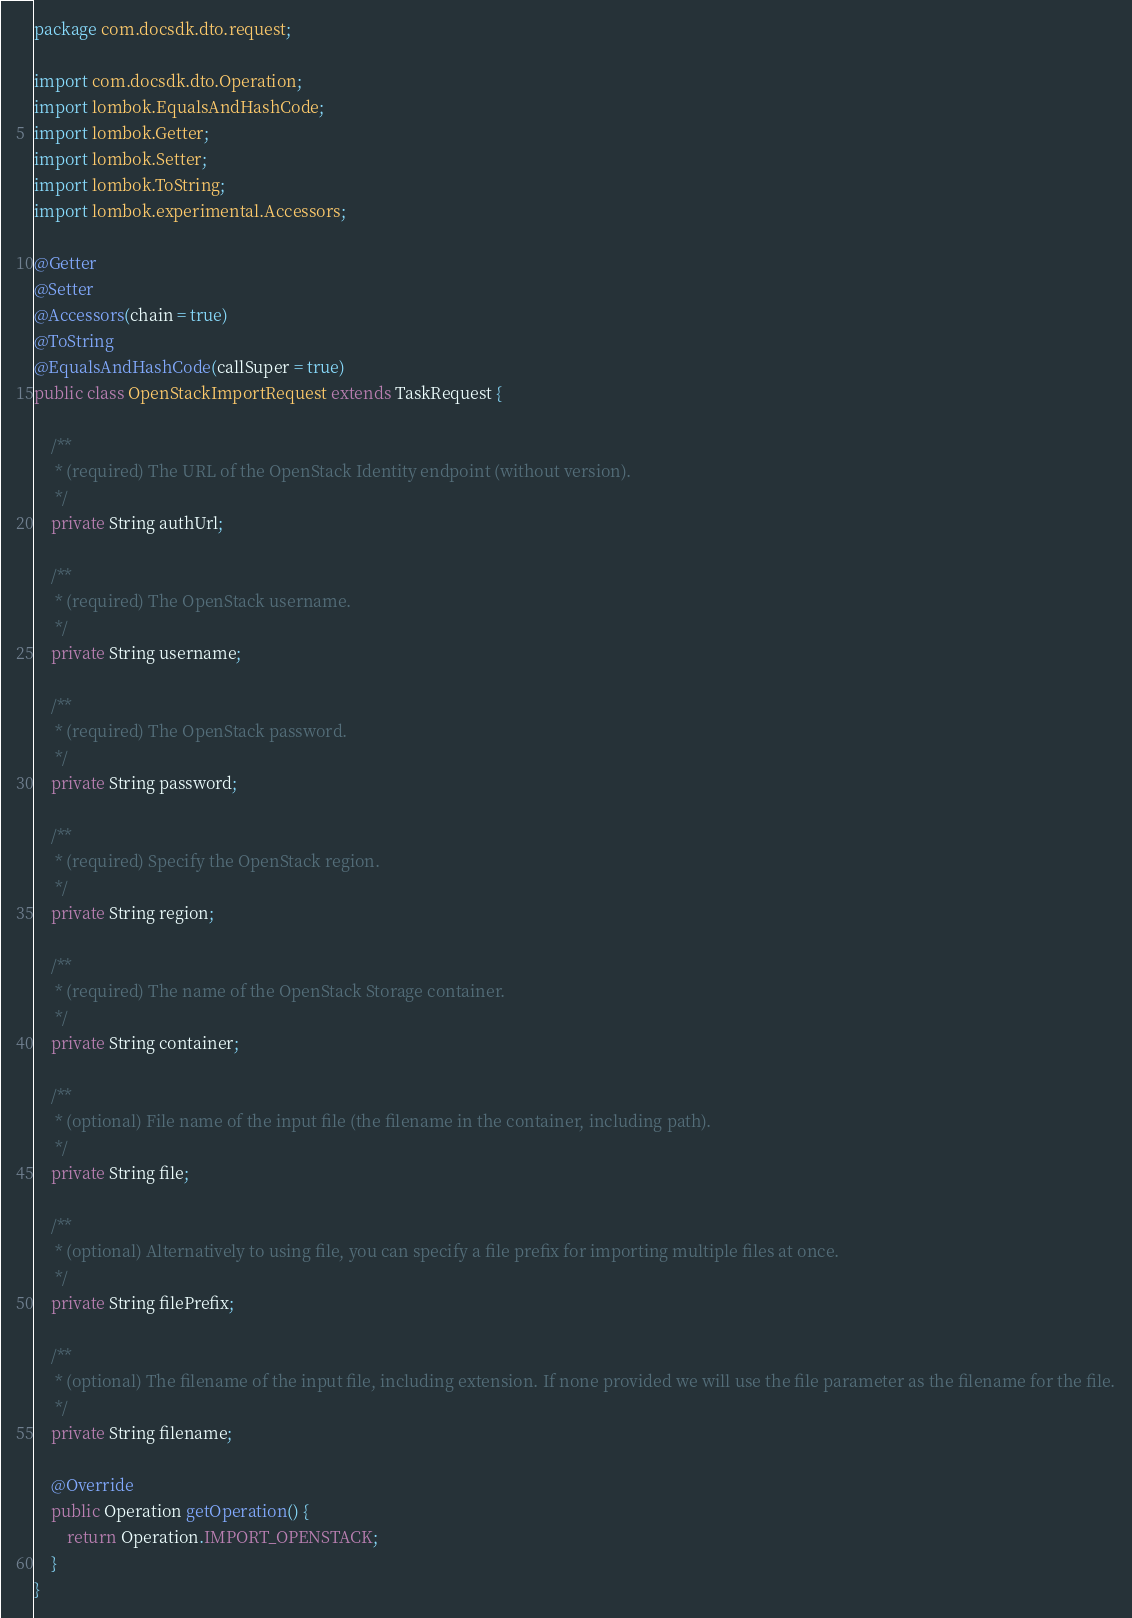Convert code to text. <code><loc_0><loc_0><loc_500><loc_500><_Java_>package com.docsdk.dto.request;

import com.docsdk.dto.Operation;
import lombok.EqualsAndHashCode;
import lombok.Getter;
import lombok.Setter;
import lombok.ToString;
import lombok.experimental.Accessors;

@Getter
@Setter
@Accessors(chain = true)
@ToString
@EqualsAndHashCode(callSuper = true)
public class OpenStackImportRequest extends TaskRequest {

    /**
     * (required) The URL of the OpenStack Identity endpoint (without version).
     */
    private String authUrl;

    /**
     * (required) The OpenStack username.
     */
    private String username;

    /**
     * (required) The OpenStack password.
     */
    private String password;

    /**
     * (required) Specify the OpenStack region.
     */
    private String region;

    /**
     * (required) The name of the OpenStack Storage container.
     */
    private String container;

    /**
     * (optional) File name of the input file (the filename in the container, including path).
     */
    private String file;

    /**
     * (optional) Alternatively to using file, you can specify a file prefix for importing multiple files at once.
     */
    private String filePrefix;

    /**
     * (optional) The filename of the input file, including extension. If none provided we will use the file parameter as the filename for the file.
     */
    private String filename;

    @Override
    public Operation getOperation() {
        return Operation.IMPORT_OPENSTACK;
    }
}
</code> 